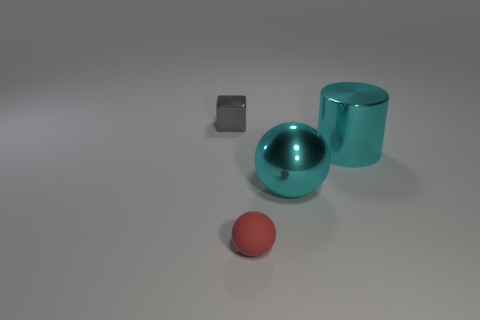There is a red object; does it have the same size as the metallic thing that is left of the small rubber sphere?
Provide a succinct answer. Yes. What number of objects are either things that are right of the red ball or cyan shiny objects?
Your response must be concise. 2. What shape is the small thing that is behind the small matte thing?
Offer a terse response. Cube. Are there the same number of tiny matte spheres that are behind the metal cylinder and red spheres on the right side of the red object?
Ensure brevity in your answer.  Yes. What color is the thing that is both in front of the big metal cylinder and behind the small red rubber object?
Provide a succinct answer. Cyan. The thing right of the ball behind the tiny red object is made of what material?
Provide a short and direct response. Metal. Does the rubber thing have the same size as the gray metal object?
Make the answer very short. Yes. What number of small objects are either gray things or green rubber cylinders?
Offer a very short reply. 1. There is a gray cube; how many large shiny objects are behind it?
Your answer should be very brief. 0. Is the number of blocks in front of the gray metallic block greater than the number of large yellow shiny cylinders?
Provide a short and direct response. No. 